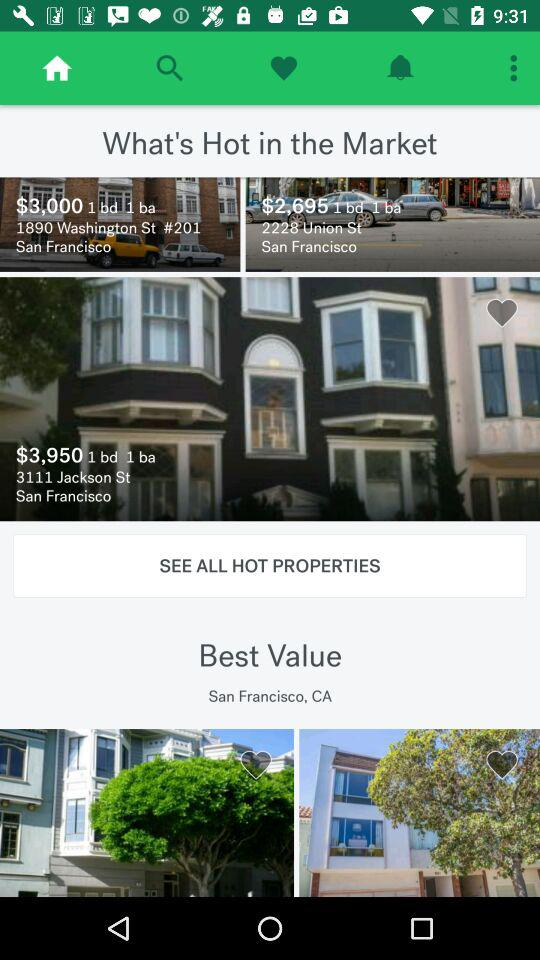What is the price of 3111 Jackson St., San Francisco? The price is $3,950. 